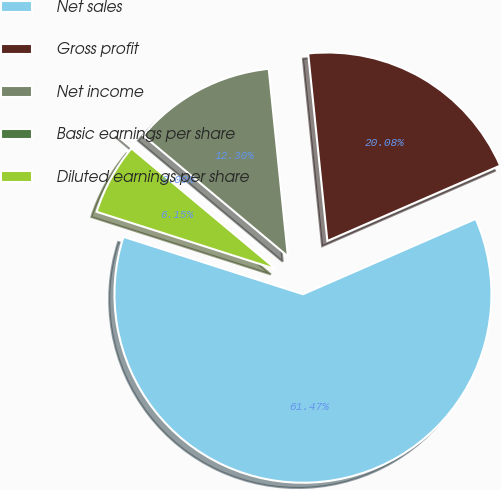Convert chart to OTSL. <chart><loc_0><loc_0><loc_500><loc_500><pie_chart><fcel>Net sales<fcel>Gross profit<fcel>Net income<fcel>Basic earnings per share<fcel>Diluted earnings per share<nl><fcel>61.48%<fcel>20.08%<fcel>12.3%<fcel>0.0%<fcel>6.15%<nl></chart> 